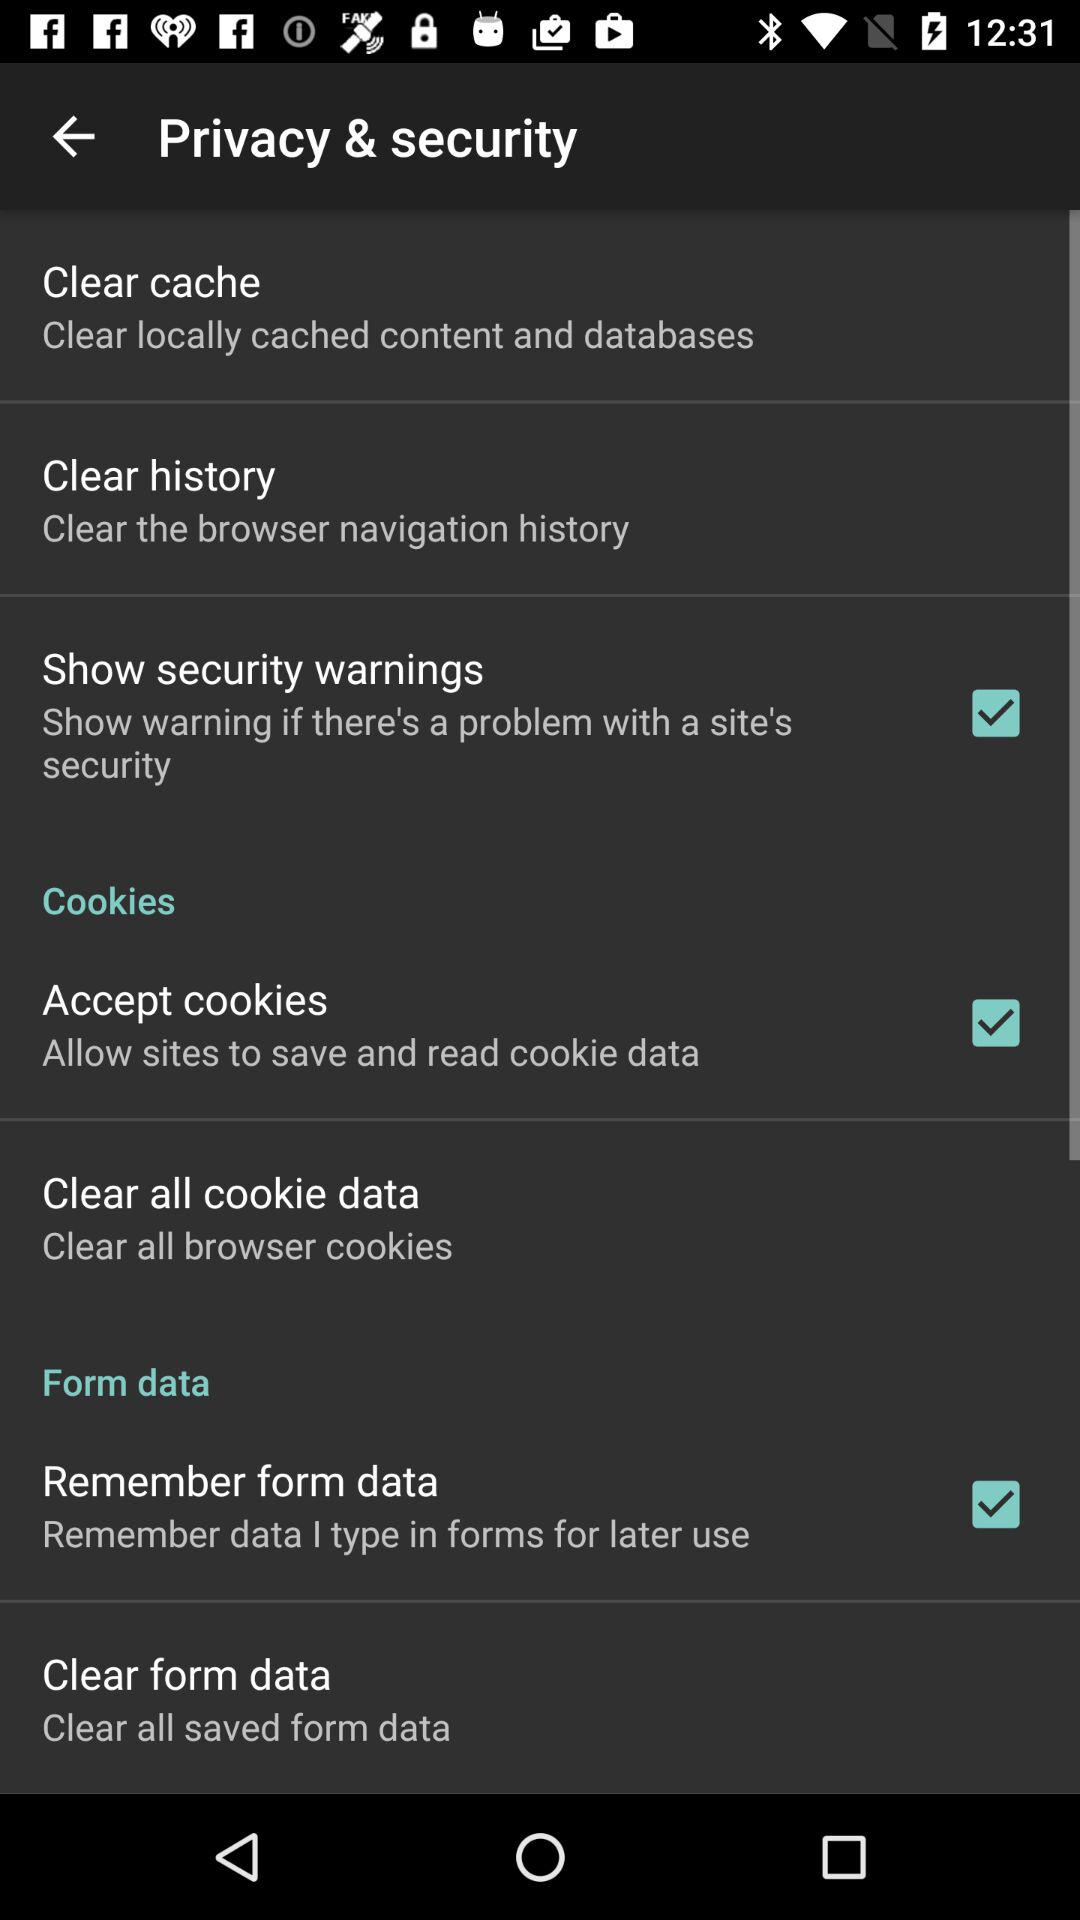Which options are checked? The checked options are "Show security warnings", "Accept cookies" and "Remember form data". 